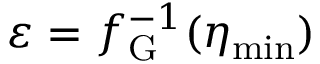Convert formula to latex. <formula><loc_0><loc_0><loc_500><loc_500>\varepsilon = f _ { G } ^ { - 1 } ( \eta _ { \min } )</formula> 